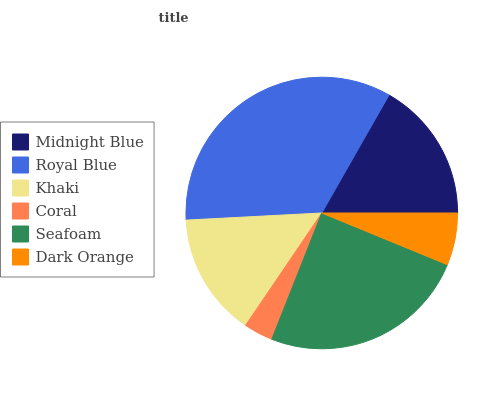Is Coral the minimum?
Answer yes or no. Yes. Is Royal Blue the maximum?
Answer yes or no. Yes. Is Khaki the minimum?
Answer yes or no. No. Is Khaki the maximum?
Answer yes or no. No. Is Royal Blue greater than Khaki?
Answer yes or no. Yes. Is Khaki less than Royal Blue?
Answer yes or no. Yes. Is Khaki greater than Royal Blue?
Answer yes or no. No. Is Royal Blue less than Khaki?
Answer yes or no. No. Is Midnight Blue the high median?
Answer yes or no. Yes. Is Khaki the low median?
Answer yes or no. Yes. Is Khaki the high median?
Answer yes or no. No. Is Coral the low median?
Answer yes or no. No. 